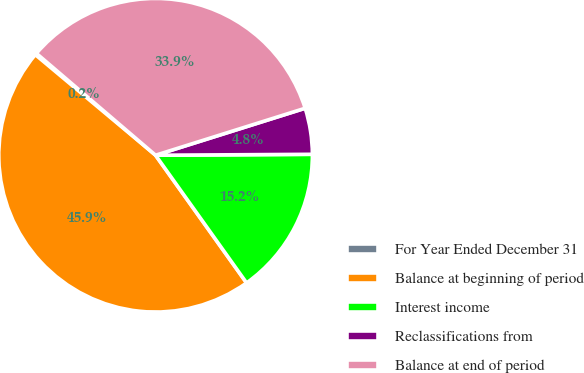<chart> <loc_0><loc_0><loc_500><loc_500><pie_chart><fcel>For Year Ended December 31<fcel>Balance at beginning of period<fcel>Interest income<fcel>Reclassifications from<fcel>Balance at end of period<nl><fcel>0.17%<fcel>45.94%<fcel>15.24%<fcel>4.75%<fcel>33.9%<nl></chart> 